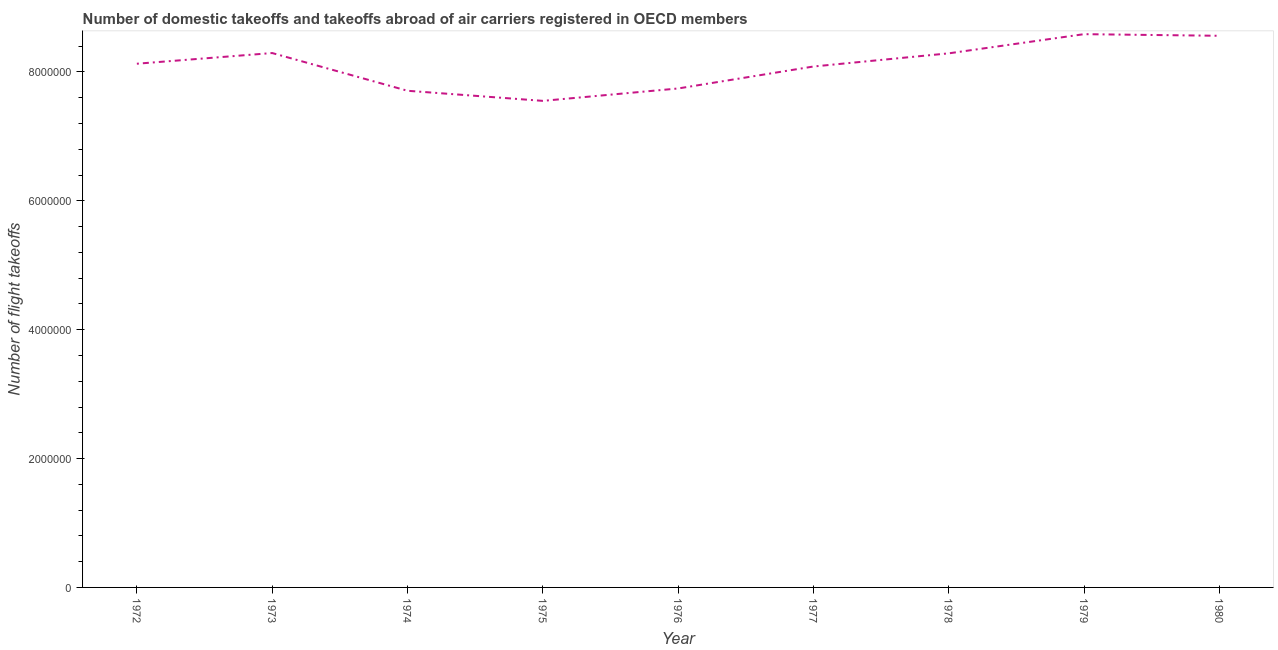What is the number of flight takeoffs in 1974?
Ensure brevity in your answer.  7.71e+06. Across all years, what is the maximum number of flight takeoffs?
Make the answer very short. 8.59e+06. Across all years, what is the minimum number of flight takeoffs?
Provide a succinct answer. 7.55e+06. In which year was the number of flight takeoffs maximum?
Provide a short and direct response. 1979. In which year was the number of flight takeoffs minimum?
Your response must be concise. 1975. What is the sum of the number of flight takeoffs?
Ensure brevity in your answer.  7.29e+07. What is the difference between the number of flight takeoffs in 1972 and 1973?
Make the answer very short. -1.66e+05. What is the average number of flight takeoffs per year?
Your answer should be compact. 8.11e+06. What is the median number of flight takeoffs?
Keep it short and to the point. 8.13e+06. What is the ratio of the number of flight takeoffs in 1976 to that in 1978?
Provide a succinct answer. 0.93. Is the number of flight takeoffs in 1973 less than that in 1977?
Provide a succinct answer. No. What is the difference between the highest and the second highest number of flight takeoffs?
Make the answer very short. 2.53e+04. What is the difference between the highest and the lowest number of flight takeoffs?
Offer a terse response. 1.04e+06. How many lines are there?
Your answer should be very brief. 1. What is the difference between two consecutive major ticks on the Y-axis?
Offer a very short reply. 2.00e+06. Are the values on the major ticks of Y-axis written in scientific E-notation?
Provide a short and direct response. No. What is the title of the graph?
Make the answer very short. Number of domestic takeoffs and takeoffs abroad of air carriers registered in OECD members. What is the label or title of the Y-axis?
Keep it short and to the point. Number of flight takeoffs. What is the Number of flight takeoffs in 1972?
Offer a terse response. 8.13e+06. What is the Number of flight takeoffs in 1973?
Ensure brevity in your answer.  8.29e+06. What is the Number of flight takeoffs in 1974?
Your response must be concise. 7.71e+06. What is the Number of flight takeoffs of 1975?
Keep it short and to the point. 7.55e+06. What is the Number of flight takeoffs in 1976?
Make the answer very short. 7.74e+06. What is the Number of flight takeoffs in 1977?
Ensure brevity in your answer.  8.08e+06. What is the Number of flight takeoffs in 1978?
Provide a short and direct response. 8.29e+06. What is the Number of flight takeoffs of 1979?
Make the answer very short. 8.59e+06. What is the Number of flight takeoffs in 1980?
Offer a very short reply. 8.56e+06. What is the difference between the Number of flight takeoffs in 1972 and 1973?
Give a very brief answer. -1.66e+05. What is the difference between the Number of flight takeoffs in 1972 and 1974?
Keep it short and to the point. 4.20e+05. What is the difference between the Number of flight takeoffs in 1972 and 1975?
Keep it short and to the point. 5.76e+05. What is the difference between the Number of flight takeoffs in 1972 and 1976?
Offer a very short reply. 3.84e+05. What is the difference between the Number of flight takeoffs in 1972 and 1977?
Provide a succinct answer. 4.30e+04. What is the difference between the Number of flight takeoffs in 1972 and 1978?
Make the answer very short. -1.61e+05. What is the difference between the Number of flight takeoffs in 1972 and 1979?
Provide a short and direct response. -4.59e+05. What is the difference between the Number of flight takeoffs in 1972 and 1980?
Provide a succinct answer. -4.34e+05. What is the difference between the Number of flight takeoffs in 1973 and 1974?
Offer a terse response. 5.86e+05. What is the difference between the Number of flight takeoffs in 1973 and 1975?
Provide a succinct answer. 7.42e+05. What is the difference between the Number of flight takeoffs in 1973 and 1976?
Your answer should be compact. 5.50e+05. What is the difference between the Number of flight takeoffs in 1973 and 1977?
Offer a very short reply. 2.09e+05. What is the difference between the Number of flight takeoffs in 1973 and 1978?
Offer a terse response. 4700. What is the difference between the Number of flight takeoffs in 1973 and 1979?
Keep it short and to the point. -2.93e+05. What is the difference between the Number of flight takeoffs in 1973 and 1980?
Your response must be concise. -2.68e+05. What is the difference between the Number of flight takeoffs in 1974 and 1975?
Provide a short and direct response. 1.57e+05. What is the difference between the Number of flight takeoffs in 1974 and 1976?
Offer a terse response. -3.56e+04. What is the difference between the Number of flight takeoffs in 1974 and 1977?
Give a very brief answer. -3.77e+05. What is the difference between the Number of flight takeoffs in 1974 and 1978?
Make the answer very short. -5.81e+05. What is the difference between the Number of flight takeoffs in 1974 and 1979?
Make the answer very short. -8.78e+05. What is the difference between the Number of flight takeoffs in 1974 and 1980?
Provide a short and direct response. -8.53e+05. What is the difference between the Number of flight takeoffs in 1975 and 1976?
Give a very brief answer. -1.92e+05. What is the difference between the Number of flight takeoffs in 1975 and 1977?
Offer a terse response. -5.33e+05. What is the difference between the Number of flight takeoffs in 1975 and 1978?
Keep it short and to the point. -7.38e+05. What is the difference between the Number of flight takeoffs in 1975 and 1979?
Your response must be concise. -1.04e+06. What is the difference between the Number of flight takeoffs in 1975 and 1980?
Provide a short and direct response. -1.01e+06. What is the difference between the Number of flight takeoffs in 1976 and 1977?
Give a very brief answer. -3.41e+05. What is the difference between the Number of flight takeoffs in 1976 and 1978?
Offer a terse response. -5.45e+05. What is the difference between the Number of flight takeoffs in 1976 and 1979?
Your response must be concise. -8.43e+05. What is the difference between the Number of flight takeoffs in 1976 and 1980?
Keep it short and to the point. -8.18e+05. What is the difference between the Number of flight takeoffs in 1977 and 1978?
Your response must be concise. -2.04e+05. What is the difference between the Number of flight takeoffs in 1977 and 1979?
Your answer should be compact. -5.02e+05. What is the difference between the Number of flight takeoffs in 1977 and 1980?
Your answer should be compact. -4.77e+05. What is the difference between the Number of flight takeoffs in 1978 and 1979?
Keep it short and to the point. -2.98e+05. What is the difference between the Number of flight takeoffs in 1978 and 1980?
Your answer should be compact. -2.72e+05. What is the difference between the Number of flight takeoffs in 1979 and 1980?
Give a very brief answer. 2.53e+04. What is the ratio of the Number of flight takeoffs in 1972 to that in 1973?
Your response must be concise. 0.98. What is the ratio of the Number of flight takeoffs in 1972 to that in 1974?
Give a very brief answer. 1.05. What is the ratio of the Number of flight takeoffs in 1972 to that in 1975?
Offer a terse response. 1.08. What is the ratio of the Number of flight takeoffs in 1972 to that in 1977?
Provide a succinct answer. 1. What is the ratio of the Number of flight takeoffs in 1972 to that in 1979?
Your answer should be compact. 0.95. What is the ratio of the Number of flight takeoffs in 1972 to that in 1980?
Your answer should be compact. 0.95. What is the ratio of the Number of flight takeoffs in 1973 to that in 1974?
Offer a very short reply. 1.08. What is the ratio of the Number of flight takeoffs in 1973 to that in 1975?
Provide a short and direct response. 1.1. What is the ratio of the Number of flight takeoffs in 1973 to that in 1976?
Your response must be concise. 1.07. What is the ratio of the Number of flight takeoffs in 1973 to that in 1979?
Your answer should be compact. 0.97. What is the ratio of the Number of flight takeoffs in 1974 to that in 1977?
Your answer should be very brief. 0.95. What is the ratio of the Number of flight takeoffs in 1974 to that in 1978?
Offer a very short reply. 0.93. What is the ratio of the Number of flight takeoffs in 1974 to that in 1979?
Provide a succinct answer. 0.9. What is the ratio of the Number of flight takeoffs in 1974 to that in 1980?
Provide a succinct answer. 0.9. What is the ratio of the Number of flight takeoffs in 1975 to that in 1976?
Your response must be concise. 0.97. What is the ratio of the Number of flight takeoffs in 1975 to that in 1977?
Your answer should be compact. 0.93. What is the ratio of the Number of flight takeoffs in 1975 to that in 1978?
Make the answer very short. 0.91. What is the ratio of the Number of flight takeoffs in 1975 to that in 1979?
Give a very brief answer. 0.88. What is the ratio of the Number of flight takeoffs in 1975 to that in 1980?
Your response must be concise. 0.88. What is the ratio of the Number of flight takeoffs in 1976 to that in 1977?
Offer a very short reply. 0.96. What is the ratio of the Number of flight takeoffs in 1976 to that in 1978?
Offer a very short reply. 0.93. What is the ratio of the Number of flight takeoffs in 1976 to that in 1979?
Give a very brief answer. 0.9. What is the ratio of the Number of flight takeoffs in 1976 to that in 1980?
Provide a succinct answer. 0.91. What is the ratio of the Number of flight takeoffs in 1977 to that in 1978?
Provide a short and direct response. 0.97. What is the ratio of the Number of flight takeoffs in 1977 to that in 1979?
Offer a very short reply. 0.94. What is the ratio of the Number of flight takeoffs in 1977 to that in 1980?
Make the answer very short. 0.94. What is the ratio of the Number of flight takeoffs in 1978 to that in 1979?
Your answer should be compact. 0.96. 